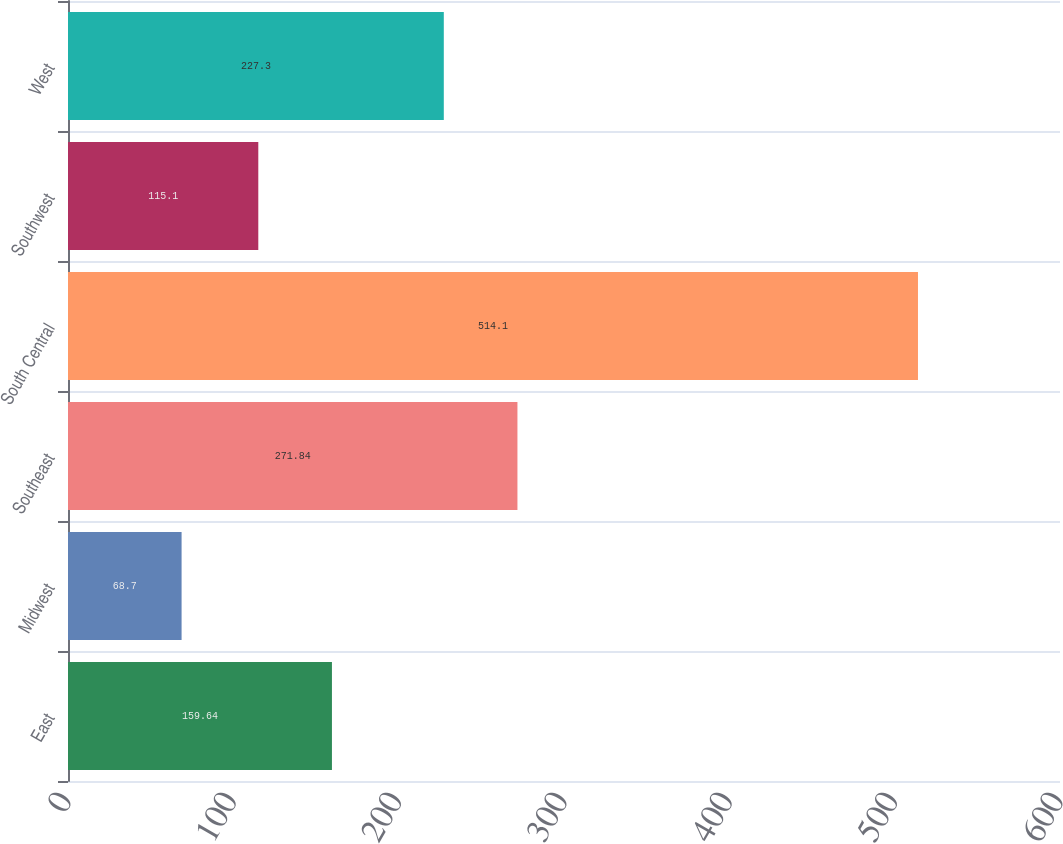Convert chart. <chart><loc_0><loc_0><loc_500><loc_500><bar_chart><fcel>East<fcel>Midwest<fcel>Southeast<fcel>South Central<fcel>Southwest<fcel>West<nl><fcel>159.64<fcel>68.7<fcel>271.84<fcel>514.1<fcel>115.1<fcel>227.3<nl></chart> 